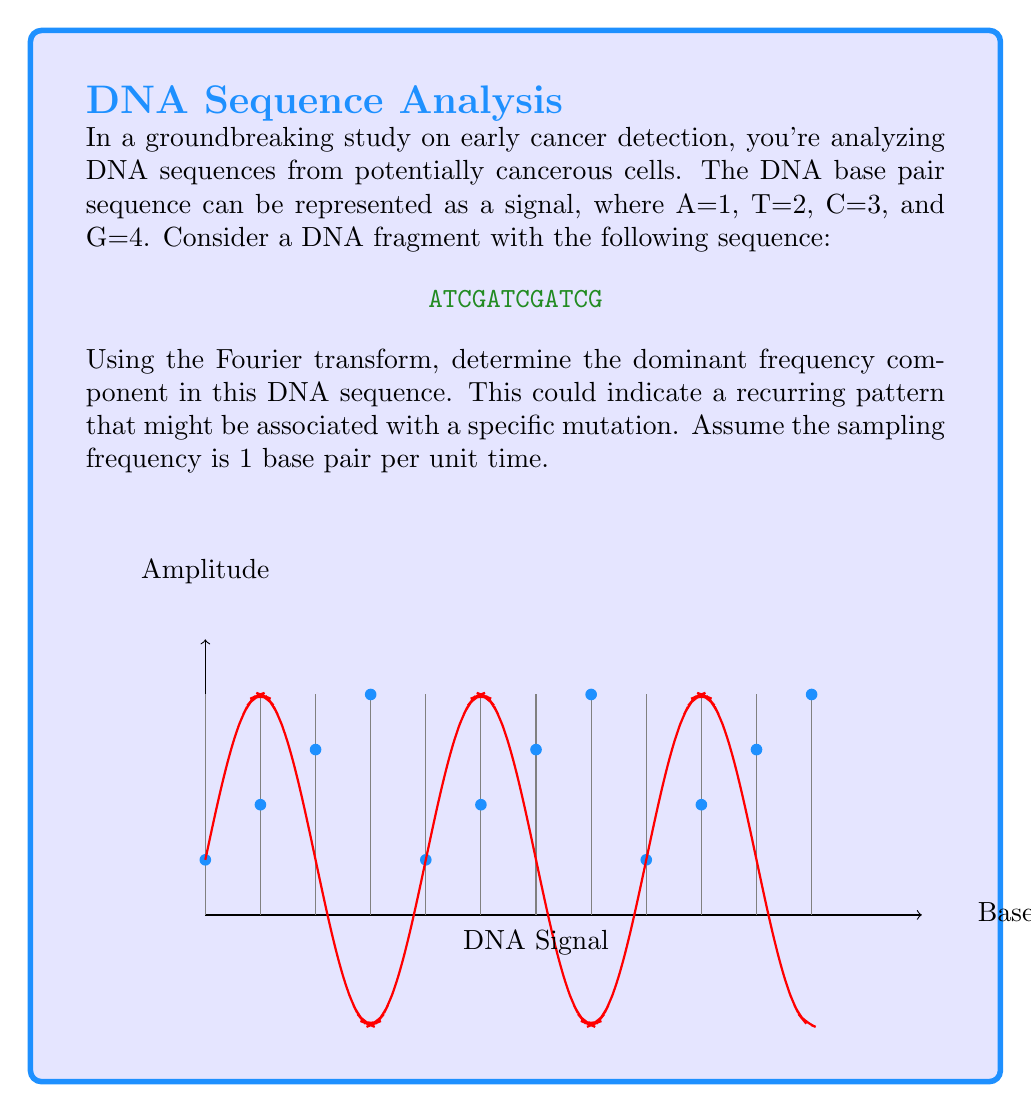Solve this math problem. Let's approach this step-by-step:

1) First, we need to convert the DNA sequence to a numerical signal:
   ATCGATCGATCG → [1,2,3,4,1,2,3,4,1,2,3,4]

2) To apply the Discrete Fourier Transform (DFT), we use the formula:

   $$X[k] = \sum_{n=0}^{N-1} x[n] e^{-j2\pi kn/N}$$

   where $N$ is the length of the sequence (12 in this case), $k$ is the frequency index, and $n$ is the time index.

3) We can simplify our calculation by using the Fast Fourier Transform (FFT) algorithm. In most programming environments, this would be a single function call.

4) After applying the FFT, we get a complex-valued output. We're interested in the magnitude of these complex numbers, which represents the strength of each frequency component.

5) The frequency corresponding to each index $k$ is given by $f_k = k * f_s / N$, where $f_s$ is the sampling frequency (1 in this case).

6) When we plot the magnitude spectrum, we see peaks at $k = 0, 3, 6, 9$. The peak at $k = 0$ represents the DC component (average value), which we can ignore for our analysis.

7) The next significant peak is at $k = 3$, which corresponds to a frequency of:

   $$f_3 = 3 * 1 / 12 = 1/4$$

8) This frequency of 1/4 indicates that the pattern repeats every 4 base pairs, which matches our original sequence ATCG-ATCG-ATCG.
Answer: 1/4 (cycles per base pair) 